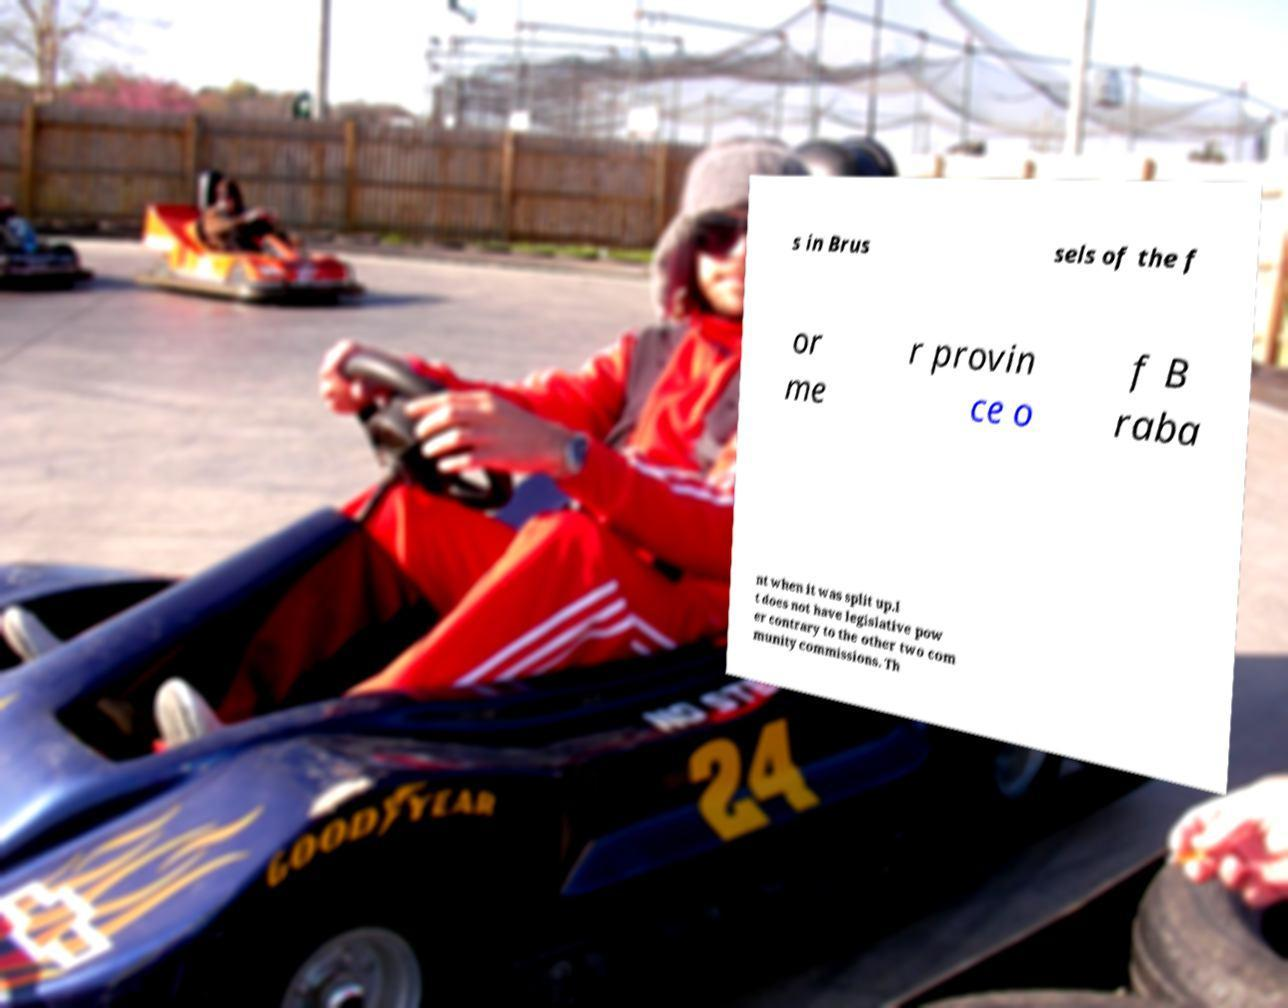For documentation purposes, I need the text within this image transcribed. Could you provide that? s in Brus sels of the f or me r provin ce o f B raba nt when it was split up.I t does not have legislative pow er contrary to the other two com munity commissions. Th 